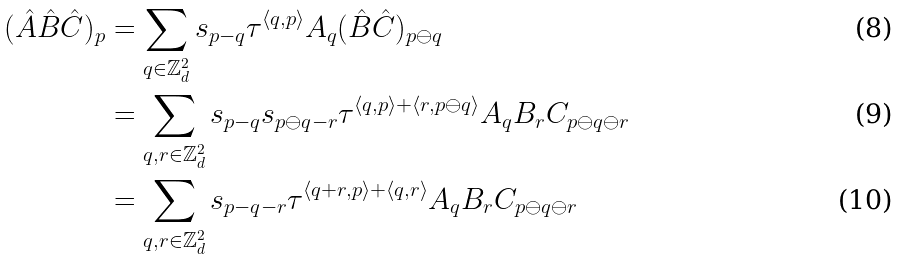<formula> <loc_0><loc_0><loc_500><loc_500>( \hat { A } \hat { B } \hat { C } ) _ { p } & = \sum _ { q \in \mathbb { Z } _ { d } ^ { 2 } } s _ { p - q } \tau ^ { \langle q , p \rangle } A _ { q } ( \hat { B } \hat { C } ) _ { p \ominus q } \\ & = \sum _ { q , r \in \mathbb { Z } _ { d } ^ { 2 } } s _ { p - q } s _ { p \ominus q - r } \tau ^ { \langle q , p \rangle + \langle r , p \ominus q \rangle } A _ { q } B _ { r } C _ { p \ominus q \ominus r } \\ & = \sum _ { q , r \in \mathbb { Z } _ { d } ^ { 2 } } s _ { p - q - r } \tau ^ { \langle q + r , p \rangle + \langle q , r \rangle } A _ { q } B _ { r } C _ { p \ominus q \ominus r }</formula> 